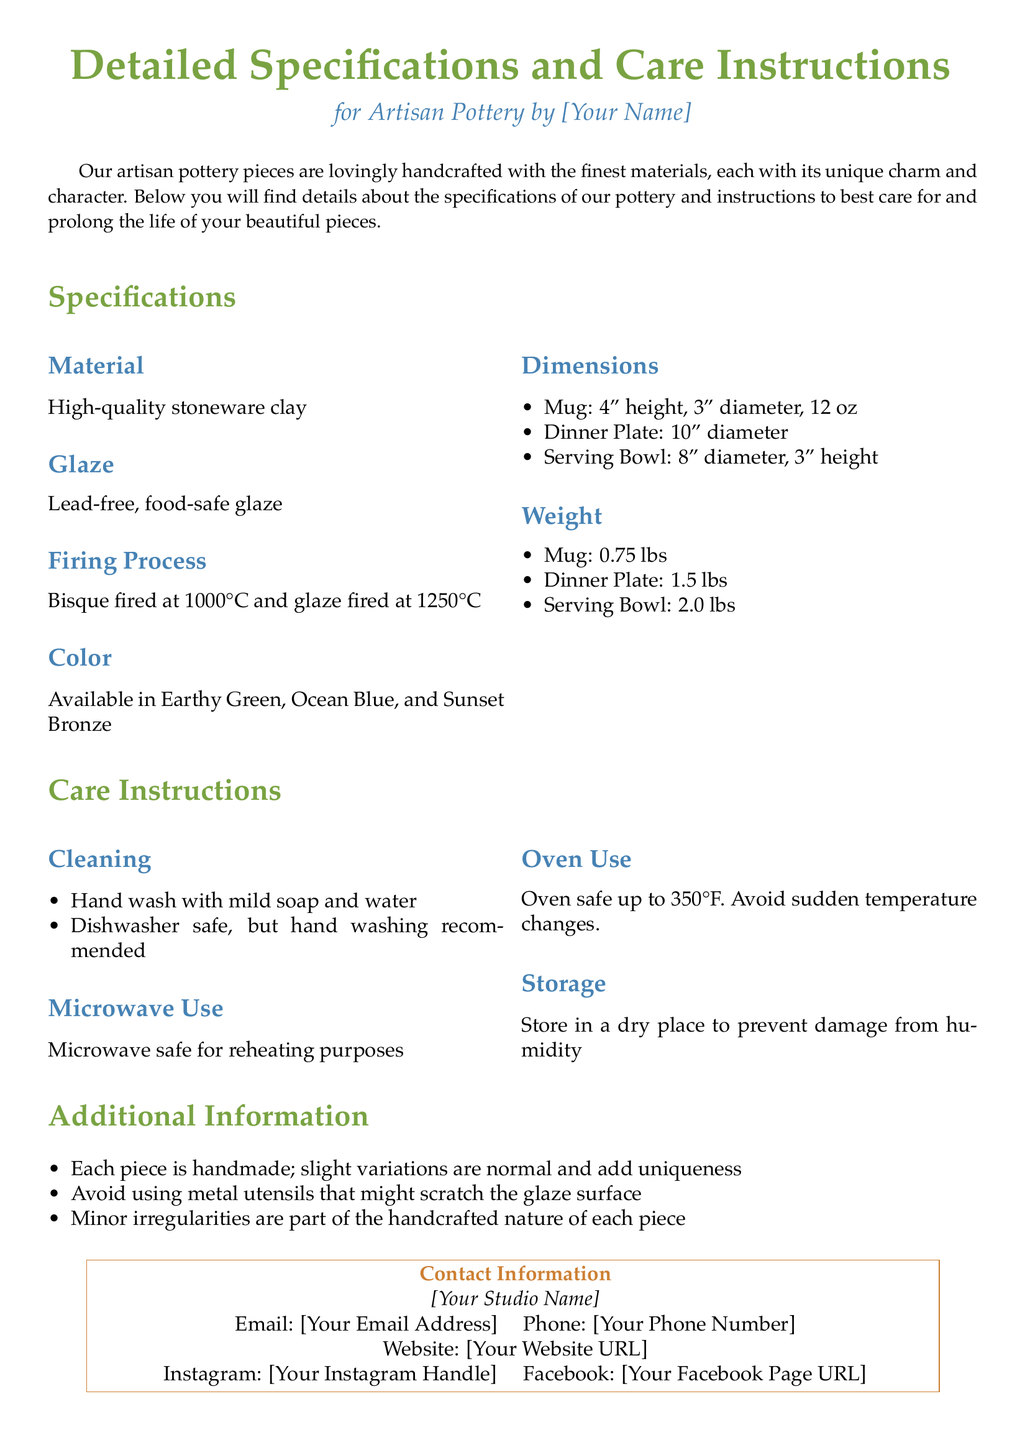What material is used for the pottery? The document states that high-quality stoneware clay is used for the pottery.
Answer: High-quality stoneware clay What are the available colors for the pottery? The document lists three colors available for the pottery: Earthy Green, Ocean Blue, and Sunset Bronze.
Answer: Earthy Green, Ocean Blue, Sunset Bronze How tall is the mug? The mug's height specification is clearly stated in the document.
Answer: 4 inches What is the recommended cleaning method? The document specifies to hand wash with mild soap and water for cleaning.
Answer: Hand wash with mild soap and water Is the pottery microwave safe? The document mentions whether the pottery is safe for use in the microwave or not.
Answer: Microwave safe What is the maximum oven temperature the pottery can withstand? The document indicates the maximum oven temperature for the pottery.
Answer: 350°F Are the pottery pieces dishwasher safe? The document provides information on whether the pottery can be washed in a dishwasher.
Answer: Dishwasher safe How much does the serving bowl weigh? The weight of the serving bowl is listed in the specifications section of the document.
Answer: 2.0 lbs 